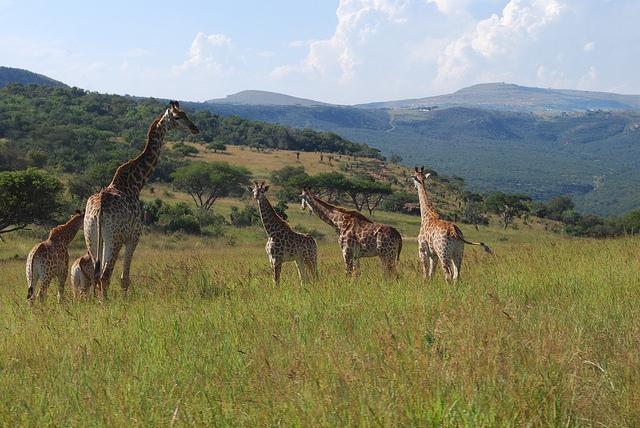How many babies?
Give a very brief answer. 2. How many giraffes are there?
Give a very brief answer. 5. How many of the people are eating?
Give a very brief answer. 0. 